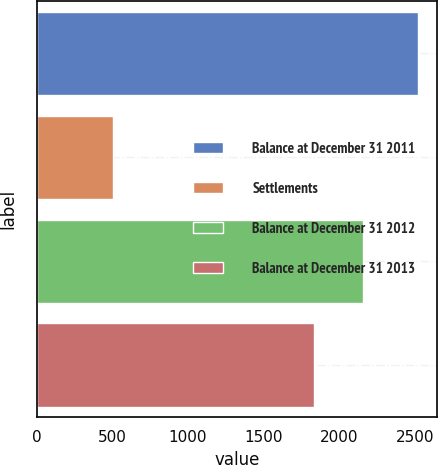<chart> <loc_0><loc_0><loc_500><loc_500><bar_chart><fcel>Balance at December 31 2011<fcel>Settlements<fcel>Balance at December 31 2012<fcel>Balance at December 31 2013<nl><fcel>2522<fcel>506<fcel>2159<fcel>1834<nl></chart> 